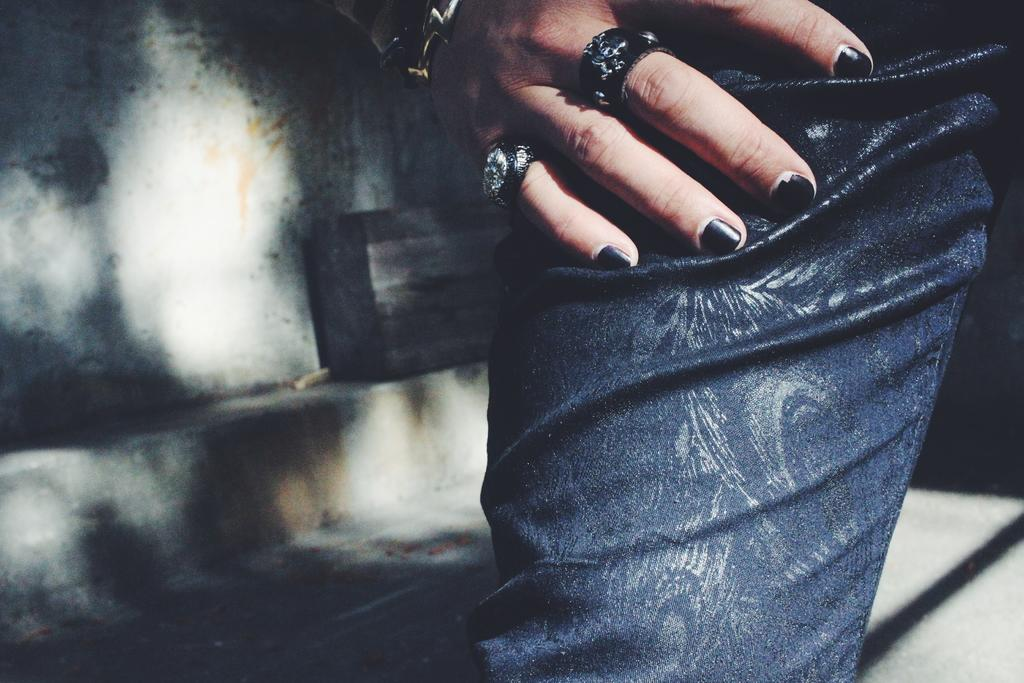What body parts of a person can be seen in the image? There is a person's leg and hand in the image. What is the person wearing on their fingers? The person is wearing rings on their fingers. What object is present in the image besides the person's body parts? There is a container in the image. What type of structure is visible in the image? There is a wall in the image. What type of disease is being treated with the crackers in the image? There is no mention of crackers or any disease in the image; it only shows a person's leg and hand, along with rings, a container, and a wall. 